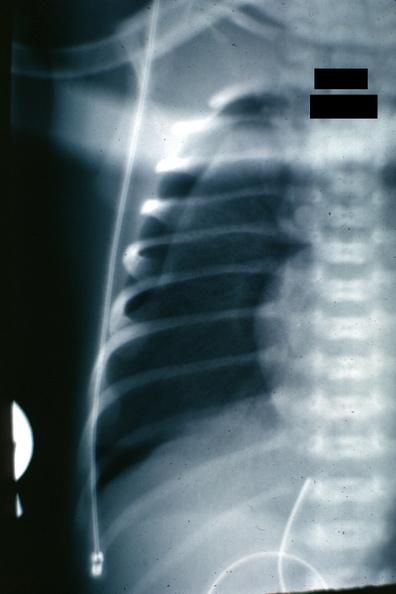what does this image show?
Answer the question using a single word or phrase. X-ray close-up to show collapsed lung very easily seen 